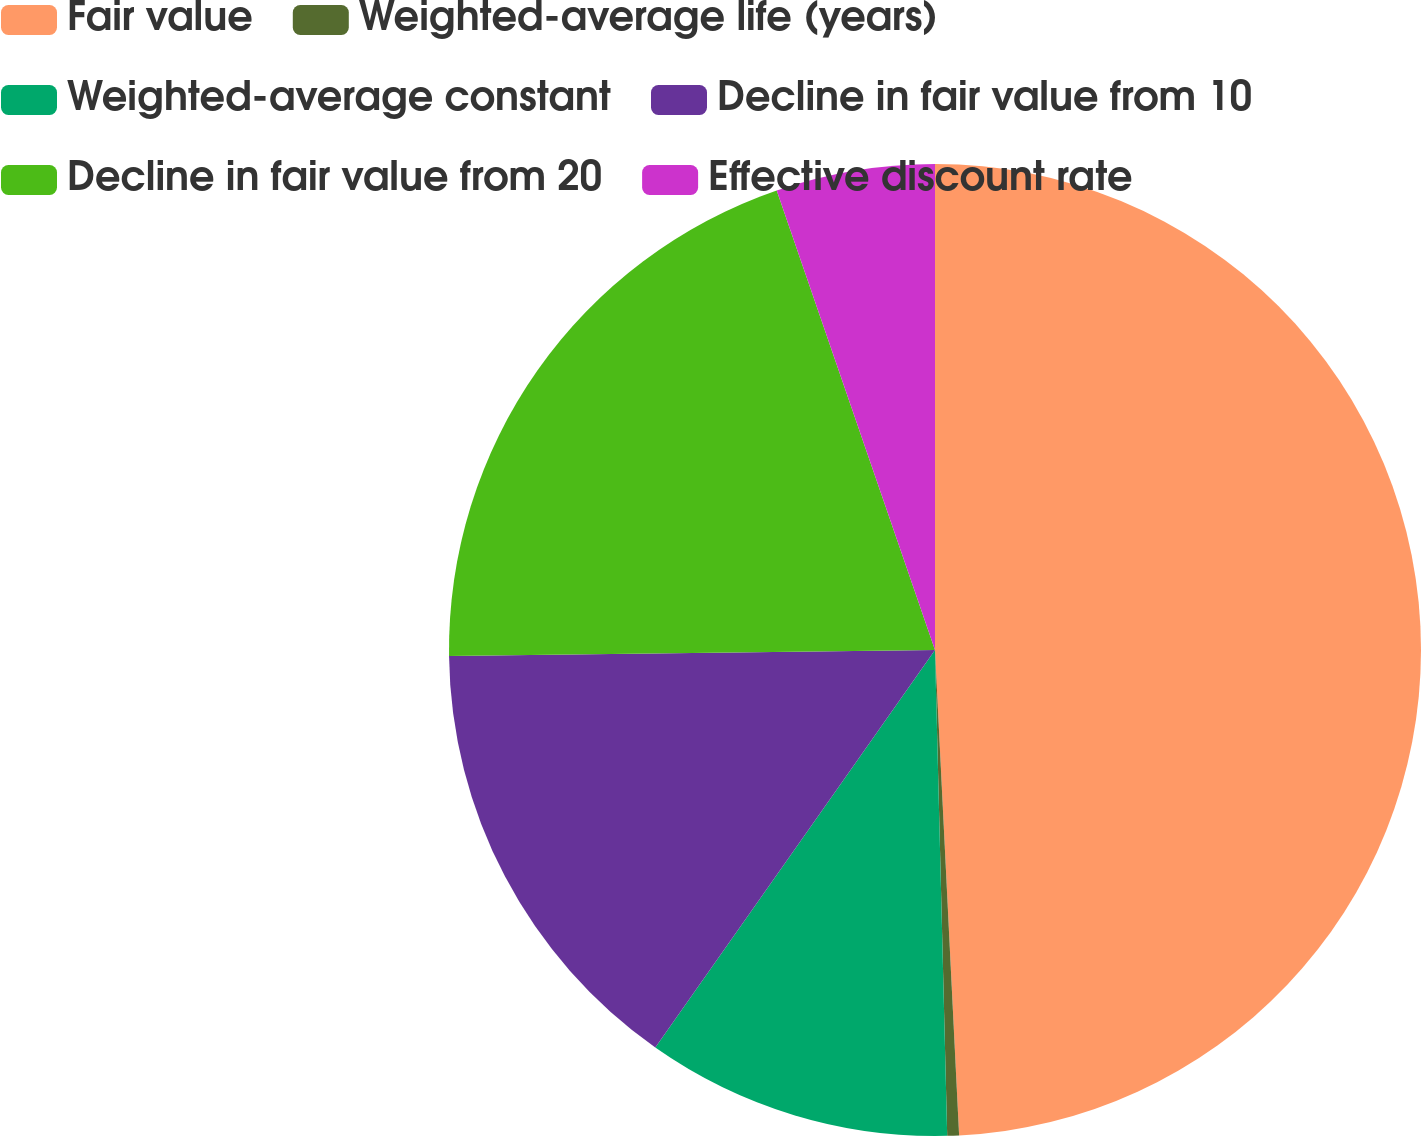<chart> <loc_0><loc_0><loc_500><loc_500><pie_chart><fcel>Fair value<fcel>Weighted-average life (years)<fcel>Weighted-average constant<fcel>Decline in fair value from 10<fcel>Decline in fair value from 20<fcel>Effective discount rate<nl><fcel>49.21%<fcel>0.39%<fcel>10.16%<fcel>15.04%<fcel>19.92%<fcel>5.28%<nl></chart> 